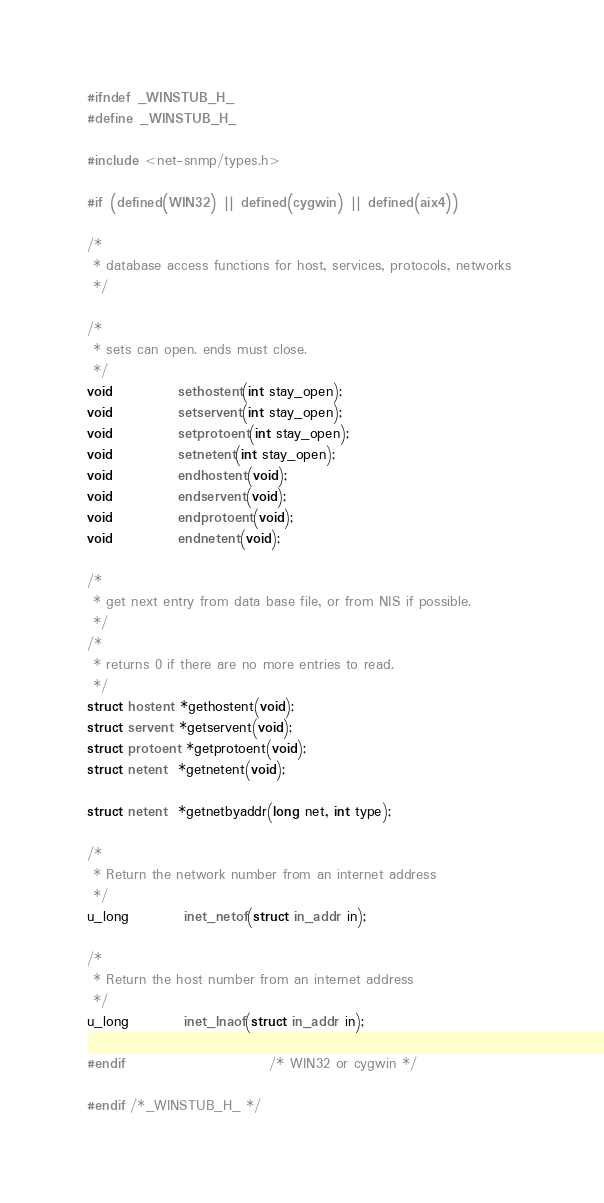Convert code to text. <code><loc_0><loc_0><loc_500><loc_500><_C_>
#ifndef _WINSTUB_H_
#define _WINSTUB_H_

#include <net-snmp/types.h>

#if (defined(WIN32) || defined(cygwin) || defined(aix4))

/*
 * database access functions for host, services, protocols, networks 
 */

/*
 * sets can open. ends must close. 
 */
void            sethostent(int stay_open);
void            setservent(int stay_open);
void            setprotoent(int stay_open);
void            setnetent(int stay_open);
void            endhostent(void);
void            endservent(void);
void            endprotoent(void);
void            endnetent(void);

/*
 * get next entry from data base file, or from NIS if possible. 
 */
/*
 * returns 0 if there are no more entries to read. 
 */
struct hostent *gethostent(void);
struct servent *getservent(void);
struct protoent *getprotoent(void);
struct netent  *getnetent(void);

struct netent  *getnetbyaddr(long net, int type);

/*
 * Return the network number from an internet address 
 */
u_long          inet_netof(struct in_addr in);

/*
 * Return the host number from an internet address 
 */
u_long          inet_lnaof(struct in_addr in);

#endif                          /* WIN32 or cygwin */

#endif /*_WINSTUB_H_ */
</code> 